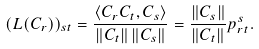<formula> <loc_0><loc_0><loc_500><loc_500>( L ( C _ { r } ) ) _ { s t } = \frac { \langle C _ { r } C _ { t } , C _ { s } \rangle } { \| C _ { t } \| \, \| C _ { s } \| } = \frac { \| C _ { s } \| } { \| C _ { t } \| } p ^ { s } _ { r t } .</formula> 